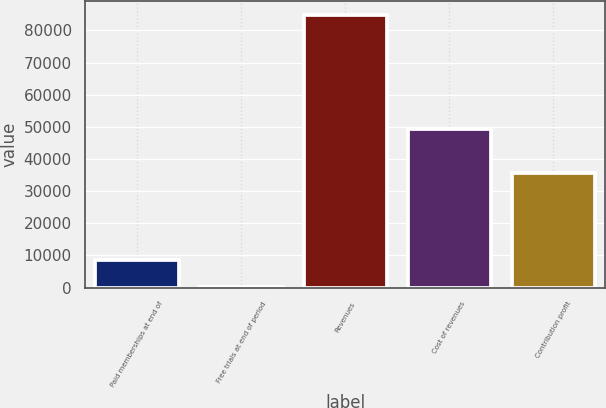Convert chart to OTSL. <chart><loc_0><loc_0><loc_500><loc_500><bar_chart><fcel>Paid memberships at end of<fcel>Free trials at end of period<fcel>Revenues<fcel>Cost of revenues<fcel>Contribution profit<nl><fcel>8516<fcel>28<fcel>84908<fcel>49428<fcel>35480<nl></chart> 